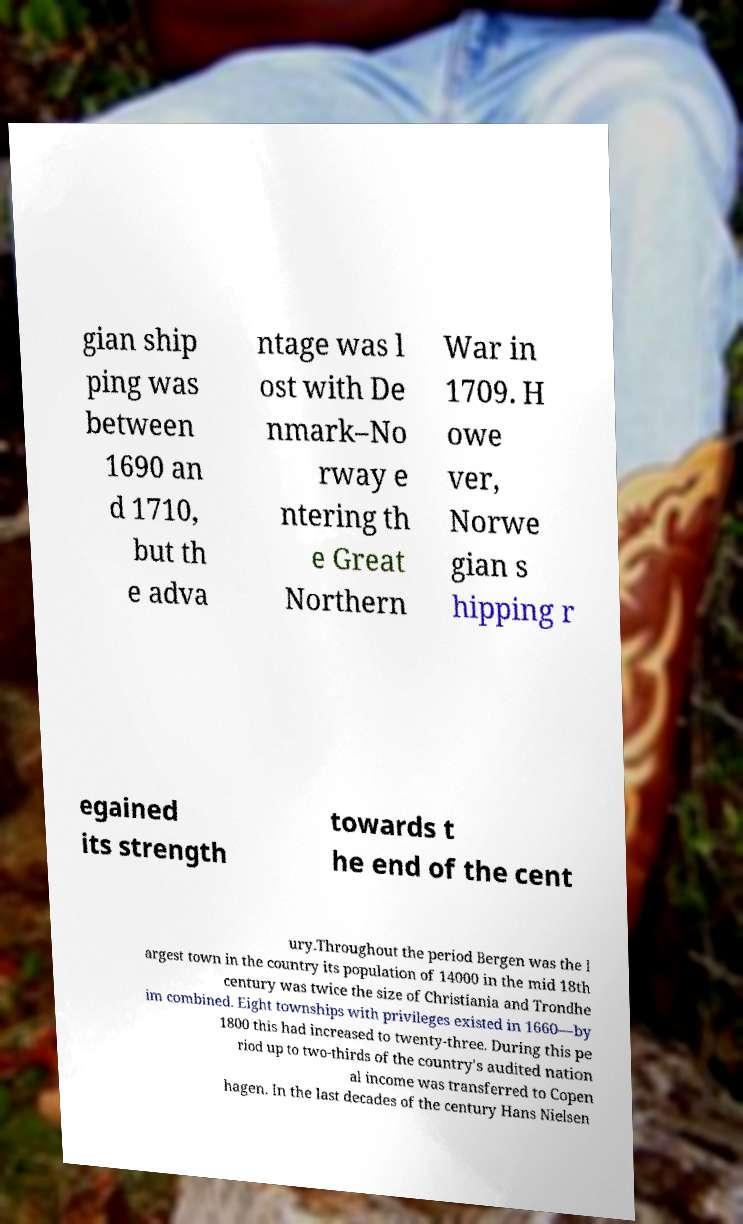What messages or text are displayed in this image? I need them in a readable, typed format. gian ship ping was between 1690 an d 1710, but th e adva ntage was l ost with De nmark–No rway e ntering th e Great Northern War in 1709. H owe ver, Norwe gian s hipping r egained its strength towards t he end of the cent ury.Throughout the period Bergen was the l argest town in the country its population of 14000 in the mid 18th century was twice the size of Christiania and Trondhe im combined. Eight townships with privileges existed in 1660—by 1800 this had increased to twenty-three. During this pe riod up to two-thirds of the country's audited nation al income was transferred to Copen hagen. In the last decades of the century Hans Nielsen 